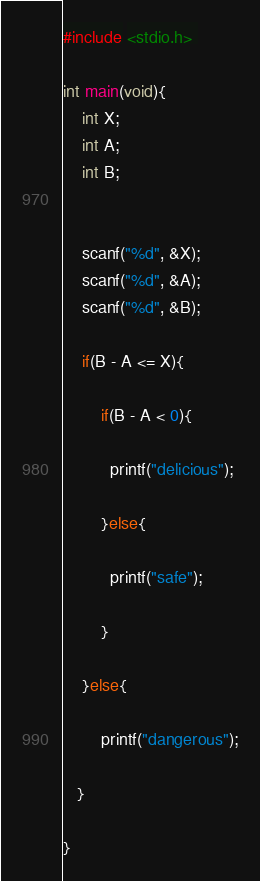Convert code to text. <code><loc_0><loc_0><loc_500><loc_500><_C_>#include <stdio.h> 

int main(void){ 
    int X;
    int A;
    int B; 
    
 
    scanf("%d", &X); 
    scanf("%d", &A); 
    scanf("%d", &B); 

    if(B - A <= X){

        if(B - A < 0){

          printf("delicious");
 
        }else{

          printf("safe");

        }

    }else{
    
        printf("dangerous");
  
   }

}</code> 